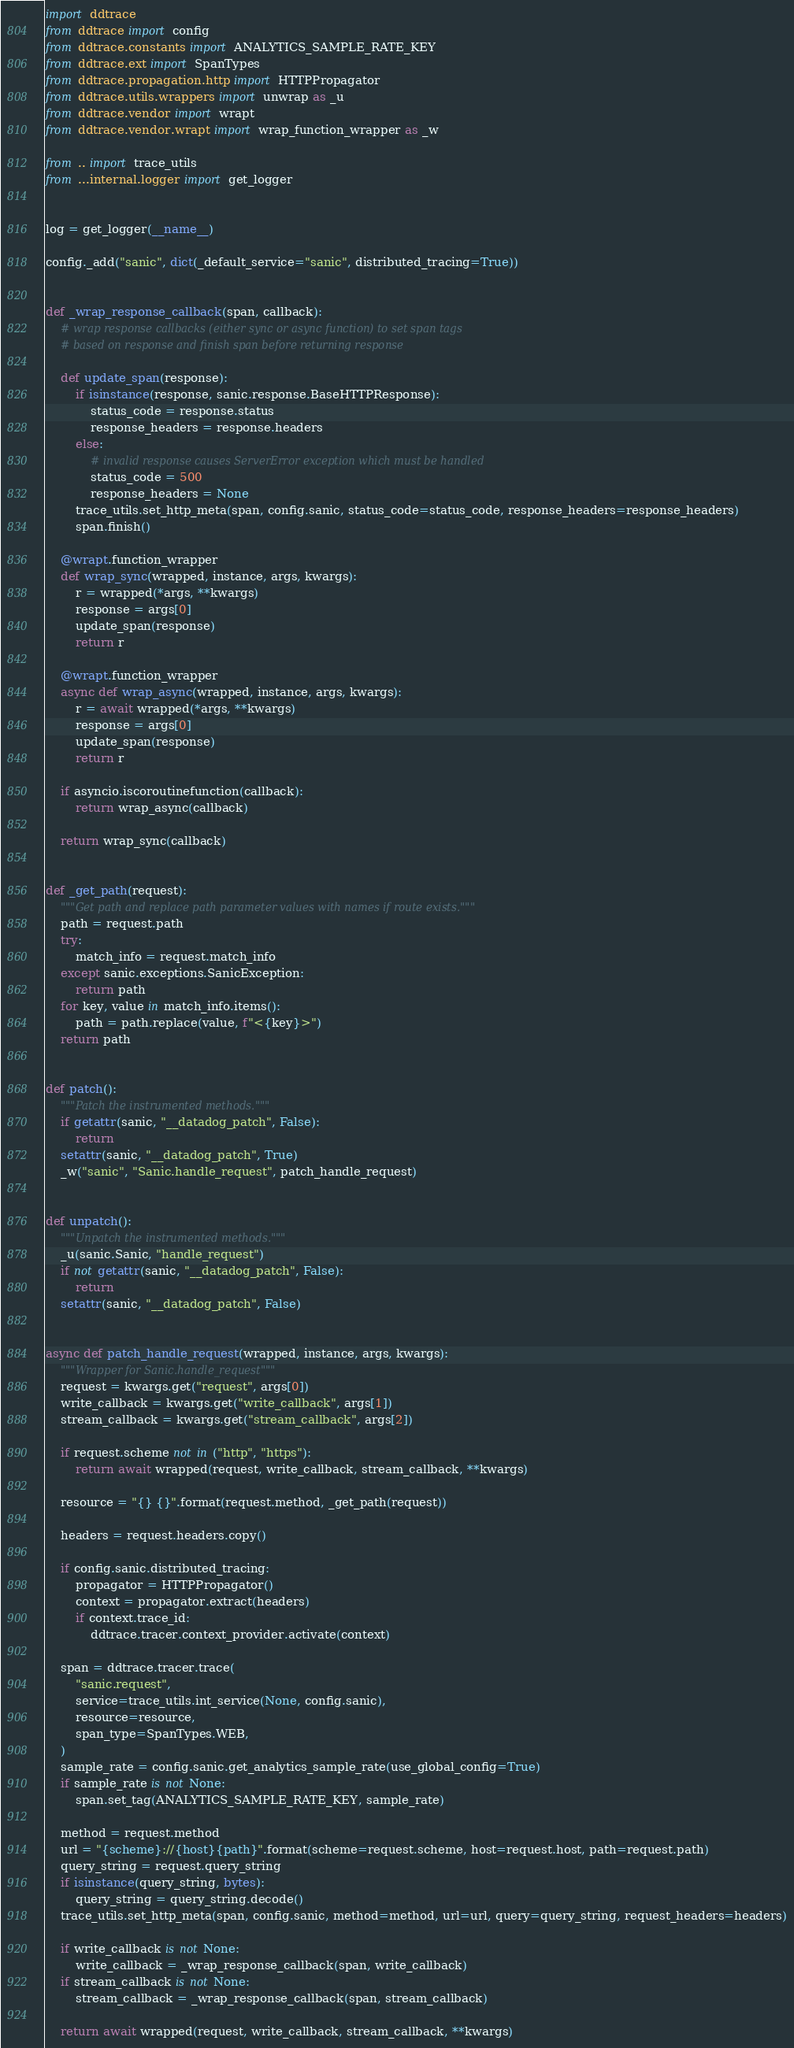Convert code to text. <code><loc_0><loc_0><loc_500><loc_500><_Python_>
import ddtrace
from ddtrace import config
from ddtrace.constants import ANALYTICS_SAMPLE_RATE_KEY
from ddtrace.ext import SpanTypes
from ddtrace.propagation.http import HTTPPropagator
from ddtrace.utils.wrappers import unwrap as _u
from ddtrace.vendor import wrapt
from ddtrace.vendor.wrapt import wrap_function_wrapper as _w

from .. import trace_utils
from ...internal.logger import get_logger


log = get_logger(__name__)

config._add("sanic", dict(_default_service="sanic", distributed_tracing=True))


def _wrap_response_callback(span, callback):
    # wrap response callbacks (either sync or async function) to set span tags
    # based on response and finish span before returning response

    def update_span(response):
        if isinstance(response, sanic.response.BaseHTTPResponse):
            status_code = response.status
            response_headers = response.headers
        else:
            # invalid response causes ServerError exception which must be handled
            status_code = 500
            response_headers = None
        trace_utils.set_http_meta(span, config.sanic, status_code=status_code, response_headers=response_headers)
        span.finish()

    @wrapt.function_wrapper
    def wrap_sync(wrapped, instance, args, kwargs):
        r = wrapped(*args, **kwargs)
        response = args[0]
        update_span(response)
        return r

    @wrapt.function_wrapper
    async def wrap_async(wrapped, instance, args, kwargs):
        r = await wrapped(*args, **kwargs)
        response = args[0]
        update_span(response)
        return r

    if asyncio.iscoroutinefunction(callback):
        return wrap_async(callback)

    return wrap_sync(callback)


def _get_path(request):
    """Get path and replace path parameter values with names if route exists."""
    path = request.path
    try:
        match_info = request.match_info
    except sanic.exceptions.SanicException:
        return path
    for key, value in match_info.items():
        path = path.replace(value, f"<{key}>")
    return path


def patch():
    """Patch the instrumented methods."""
    if getattr(sanic, "__datadog_patch", False):
        return
    setattr(sanic, "__datadog_patch", True)
    _w("sanic", "Sanic.handle_request", patch_handle_request)


def unpatch():
    """Unpatch the instrumented methods."""
    _u(sanic.Sanic, "handle_request")
    if not getattr(sanic, "__datadog_patch", False):
        return
    setattr(sanic, "__datadog_patch", False)


async def patch_handle_request(wrapped, instance, args, kwargs):
    """Wrapper for Sanic.handle_request"""
    request = kwargs.get("request", args[0])
    write_callback = kwargs.get("write_callback", args[1])
    stream_callback = kwargs.get("stream_callback", args[2])

    if request.scheme not in ("http", "https"):
        return await wrapped(request, write_callback, stream_callback, **kwargs)

    resource = "{} {}".format(request.method, _get_path(request))

    headers = request.headers.copy()

    if config.sanic.distributed_tracing:
        propagator = HTTPPropagator()
        context = propagator.extract(headers)
        if context.trace_id:
            ddtrace.tracer.context_provider.activate(context)

    span = ddtrace.tracer.trace(
        "sanic.request",
        service=trace_utils.int_service(None, config.sanic),
        resource=resource,
        span_type=SpanTypes.WEB,
    )
    sample_rate = config.sanic.get_analytics_sample_rate(use_global_config=True)
    if sample_rate is not None:
        span.set_tag(ANALYTICS_SAMPLE_RATE_KEY, sample_rate)

    method = request.method
    url = "{scheme}://{host}{path}".format(scheme=request.scheme, host=request.host, path=request.path)
    query_string = request.query_string
    if isinstance(query_string, bytes):
        query_string = query_string.decode()
    trace_utils.set_http_meta(span, config.sanic, method=method, url=url, query=query_string, request_headers=headers)

    if write_callback is not None:
        write_callback = _wrap_response_callback(span, write_callback)
    if stream_callback is not None:
        stream_callback = _wrap_response_callback(span, stream_callback)

    return await wrapped(request, write_callback, stream_callback, **kwargs)
</code> 